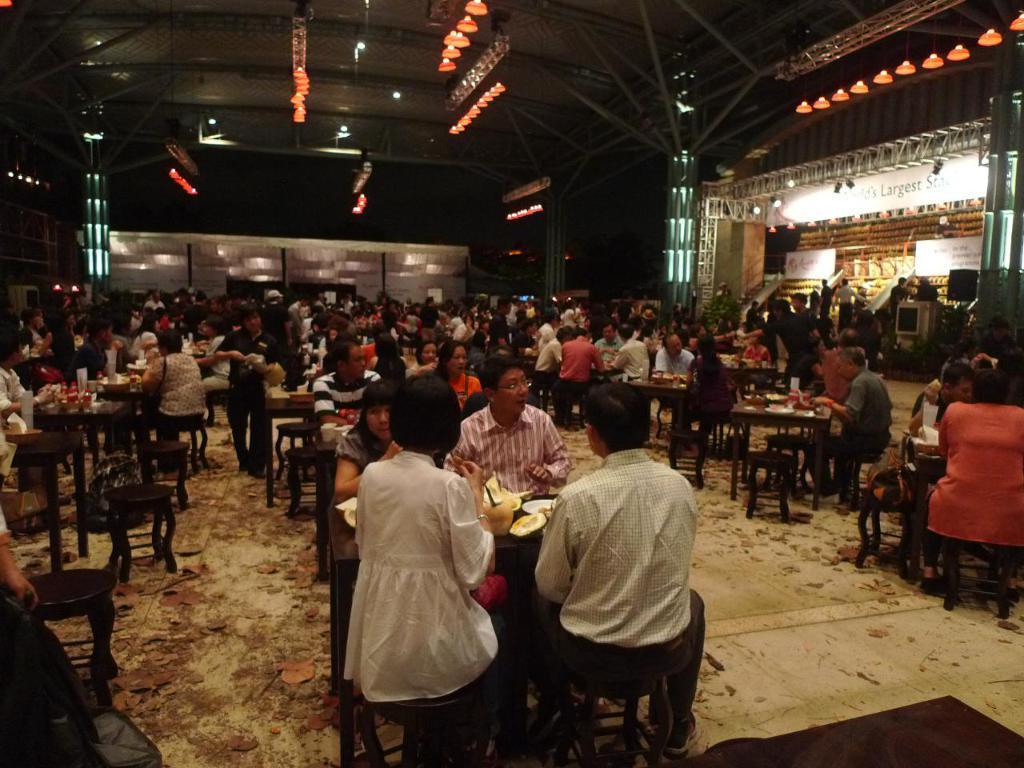Describe this image in one or two sentences. In the image we can see group of persons were sitting on the chair around the table. On table we can see some food items. In the background there is a wall,light,banner,table and few persons were standing. 